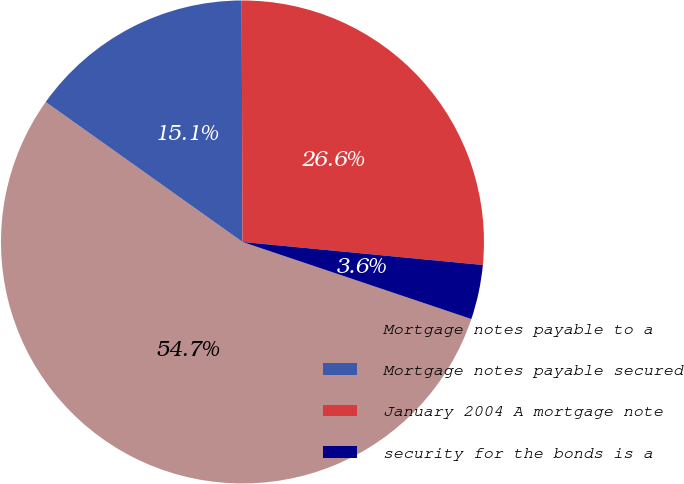<chart> <loc_0><loc_0><loc_500><loc_500><pie_chart><fcel>Mortgage notes payable to a<fcel>Mortgage notes payable secured<fcel>January 2004 A mortgage note<fcel>security for the bonds is a<nl><fcel>54.67%<fcel>15.11%<fcel>26.57%<fcel>3.65%<nl></chart> 